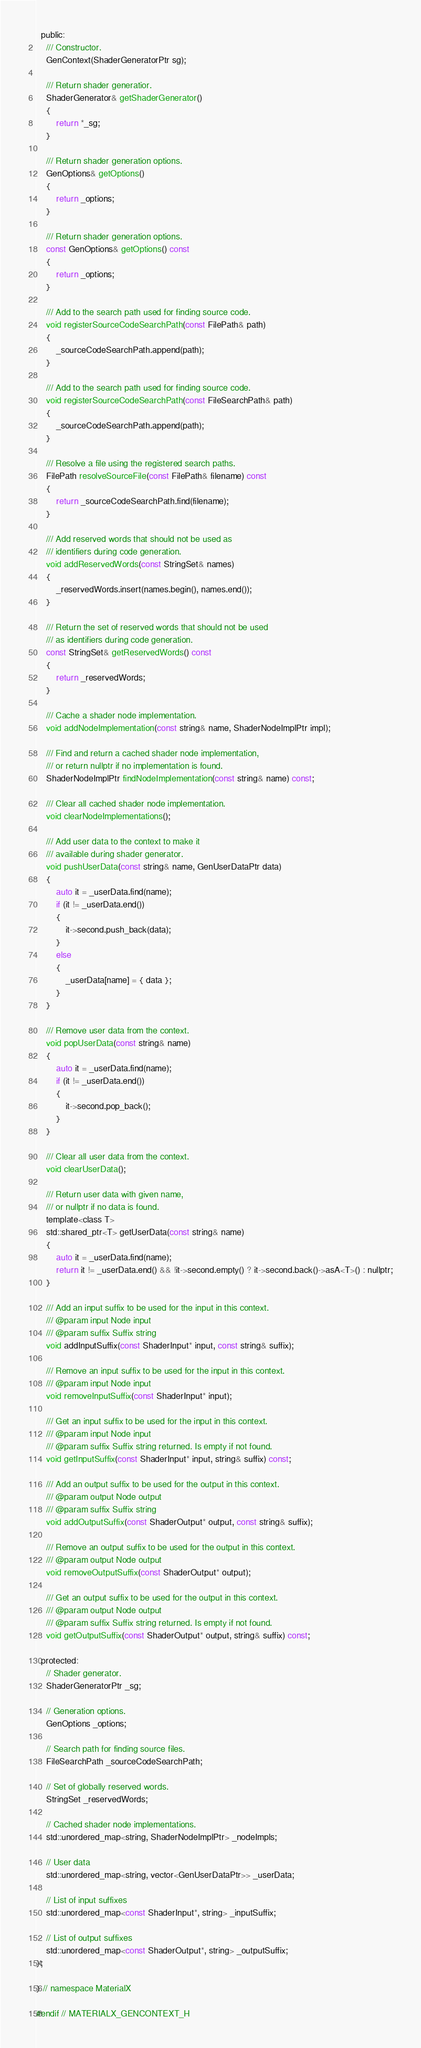Convert code to text. <code><loc_0><loc_0><loc_500><loc_500><_C_>  public:
    /// Constructor.
    GenContext(ShaderGeneratorPtr sg);

    /// Return shader generatior.
    ShaderGenerator& getShaderGenerator()
    {
        return *_sg;
    }

    /// Return shader generation options.
    GenOptions& getOptions()
    {
        return _options;
    }

    /// Return shader generation options.
    const GenOptions& getOptions() const
    {
        return _options;
    }

    /// Add to the search path used for finding source code.
    void registerSourceCodeSearchPath(const FilePath& path)
    {
        _sourceCodeSearchPath.append(path);
    }

    /// Add to the search path used for finding source code.
    void registerSourceCodeSearchPath(const FileSearchPath& path)
    {
        _sourceCodeSearchPath.append(path);
    }

    /// Resolve a file using the registered search paths.
    FilePath resolveSourceFile(const FilePath& filename) const
    {
        return _sourceCodeSearchPath.find(filename);
    }

    /// Add reserved words that should not be used as
    /// identifiers during code generation.
    void addReservedWords(const StringSet& names)
    {
        _reservedWords.insert(names.begin(), names.end());
    }

    /// Return the set of reserved words that should not be used
    /// as identifiers during code generation.
    const StringSet& getReservedWords() const
    {
        return _reservedWords;
    }

    /// Cache a shader node implementation.
    void addNodeImplementation(const string& name, ShaderNodeImplPtr impl);

    /// Find and return a cached shader node implementation,
    /// or return nullptr if no implementation is found.
    ShaderNodeImplPtr findNodeImplementation(const string& name) const;

    /// Clear all cached shader node implementation.
    void clearNodeImplementations();

    /// Add user data to the context to make it
    /// available during shader generator.
    void pushUserData(const string& name, GenUserDataPtr data)
    {
        auto it = _userData.find(name);
        if (it != _userData.end())
        {
            it->second.push_back(data);
        }
        else
        {
            _userData[name] = { data };
        }
    }

    /// Remove user data from the context.
    void popUserData(const string& name)
    {
        auto it = _userData.find(name);
        if (it != _userData.end())
        {
            it->second.pop_back();
        }
    }

    /// Clear all user data from the context.
    void clearUserData();

    /// Return user data with given name,
    /// or nullptr if no data is found.
    template<class T>
    std::shared_ptr<T> getUserData(const string& name)
    {
        auto it = _userData.find(name);
        return it != _userData.end() && !it->second.empty() ? it->second.back()->asA<T>() : nullptr;
    }

    /// Add an input suffix to be used for the input in this context.
    /// @param input Node input
    /// @param suffix Suffix string
    void addInputSuffix(const ShaderInput* input, const string& suffix);

    /// Remove an input suffix to be used for the input in this context.
    /// @param input Node input
    void removeInputSuffix(const ShaderInput* input);

    /// Get an input suffix to be used for the input in this context.
    /// @param input Node input
    /// @param suffix Suffix string returned. Is empty if not found.
    void getInputSuffix(const ShaderInput* input, string& suffix) const;

    /// Add an output suffix to be used for the output in this context.
    /// @param output Node output
    /// @param suffix Suffix string
    void addOutputSuffix(const ShaderOutput* output, const string& suffix);

    /// Remove an output suffix to be used for the output in this context.
    /// @param output Node output
    void removeOutputSuffix(const ShaderOutput* output);

    /// Get an output suffix to be used for the output in this context.
    /// @param output Node output
    /// @param suffix Suffix string returned. Is empty if not found.
    void getOutputSuffix(const ShaderOutput* output, string& suffix) const;

  protected:
    // Shader generator.
    ShaderGeneratorPtr _sg;

    // Generation options.
    GenOptions _options;

    // Search path for finding source files.
    FileSearchPath _sourceCodeSearchPath;

    // Set of globally reserved words.
    StringSet _reservedWords;

    // Cached shader node implementations.
    std::unordered_map<string, ShaderNodeImplPtr> _nodeImpls;

    // User data
    std::unordered_map<string, vector<GenUserDataPtr>> _userData;

    // List of input suffixes
    std::unordered_map<const ShaderInput*, string> _inputSuffix;

    // List of output suffixes
    std::unordered_map<const ShaderOutput*, string> _outputSuffix;
};

} // namespace MaterialX

#endif // MATERIALX_GENCONTEXT_H
</code> 